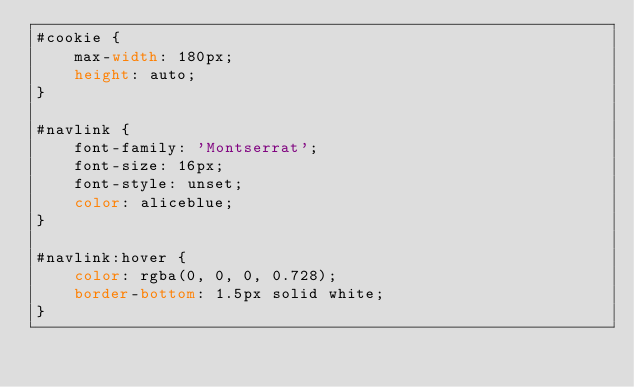<code> <loc_0><loc_0><loc_500><loc_500><_CSS_>#cookie {
    max-width: 180px;
    height: auto;
}

#navlink {
    font-family: 'Montserrat';
    font-size: 16px;
    font-style: unset;
    color: aliceblue;
}

#navlink:hover {
    color: rgba(0, 0, 0, 0.728);
    border-bottom: 1.5px solid white;
}

</code> 